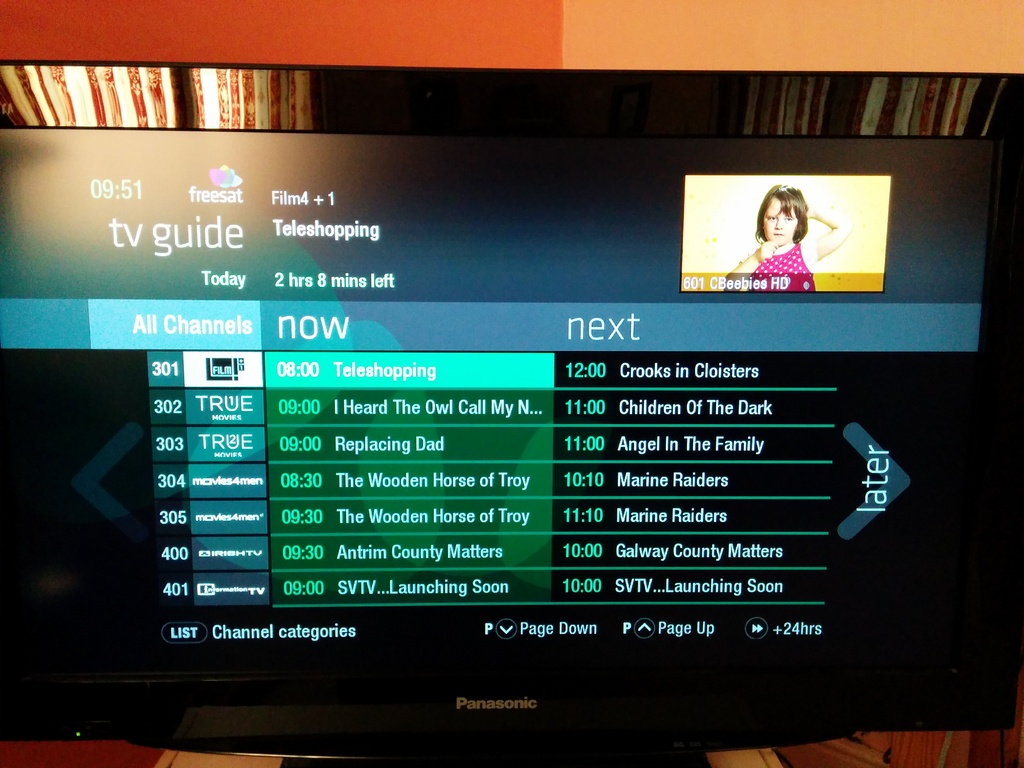Can you tell me more about the next program on the True Movies channel as per the TV guide? The next program on the True Movies channel, according to the TV guide, is 'Crooks in Cloisters' scheduled at 12:00. 